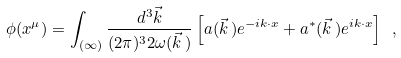Convert formula to latex. <formula><loc_0><loc_0><loc_500><loc_500>\phi ( x ^ { \mu } ) = \int _ { ( \infty ) } \frac { d ^ { 3 } \vec { k } } { ( 2 \pi ) ^ { 3 } 2 \omega ( \vec { k } \, ) } \left [ a ( \vec { k } \, ) e ^ { - i k \cdot x } + a ^ { * } ( \vec { k } \, ) e ^ { i k \cdot x } \right ] \ ,</formula> 